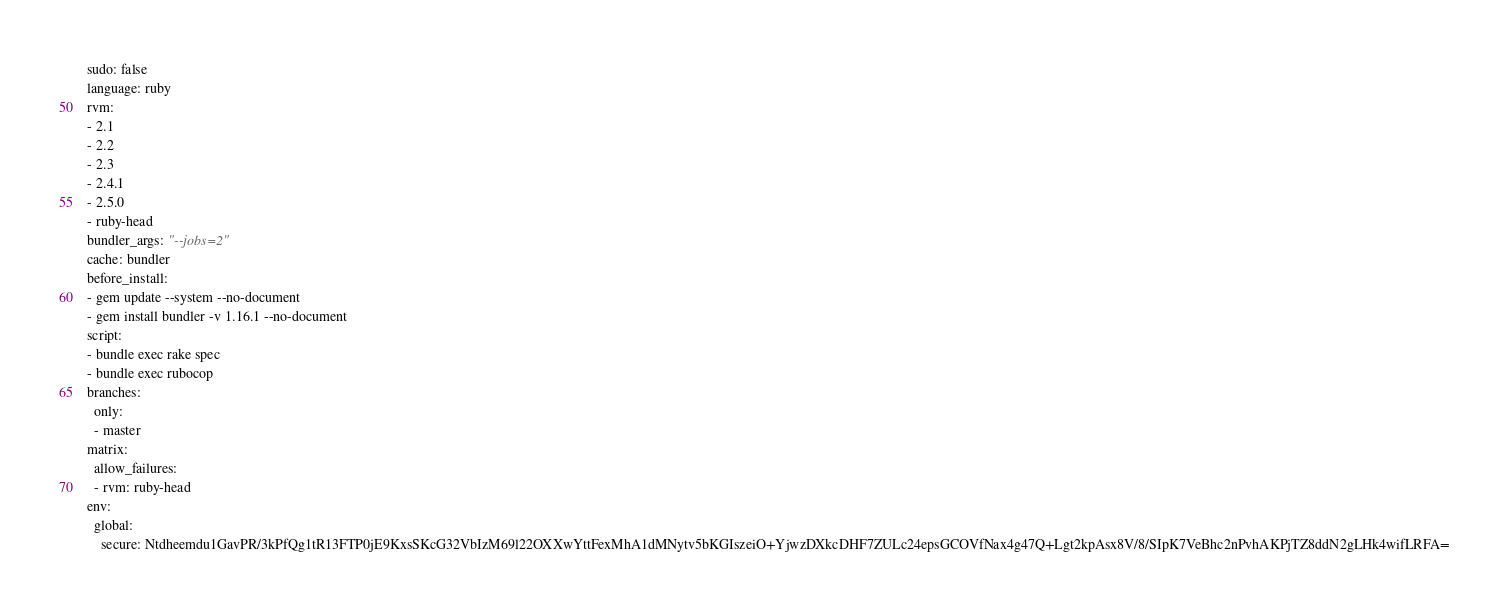Convert code to text. <code><loc_0><loc_0><loc_500><loc_500><_YAML_>sudo: false
language: ruby
rvm:
- 2.1
- 2.2
- 2.3
- 2.4.1
- 2.5.0
- ruby-head
bundler_args: "--jobs=2"
cache: bundler
before_install:
- gem update --system --no-document
- gem install bundler -v 1.16.1 --no-document
script:
- bundle exec rake spec
- bundle exec rubocop
branches:
  only:
  - master
matrix:
  allow_failures:
  - rvm: ruby-head
env:
  global:
    secure: Ntdheemdu1GavPR/3kPfQg1tR13FTP0jE9KxsSKcG32VbIzM69l22OXXwYttFexMhA1dMNytv5bKGIszeiO+YjwzDXkcDHF7ZULc24epsGCOVfNax4g47Q+Lgt2kpAsx8V/8/SIpK7VeBhc2nPvhAKPjTZ8ddN2gLHk4wifLRFA=
</code> 